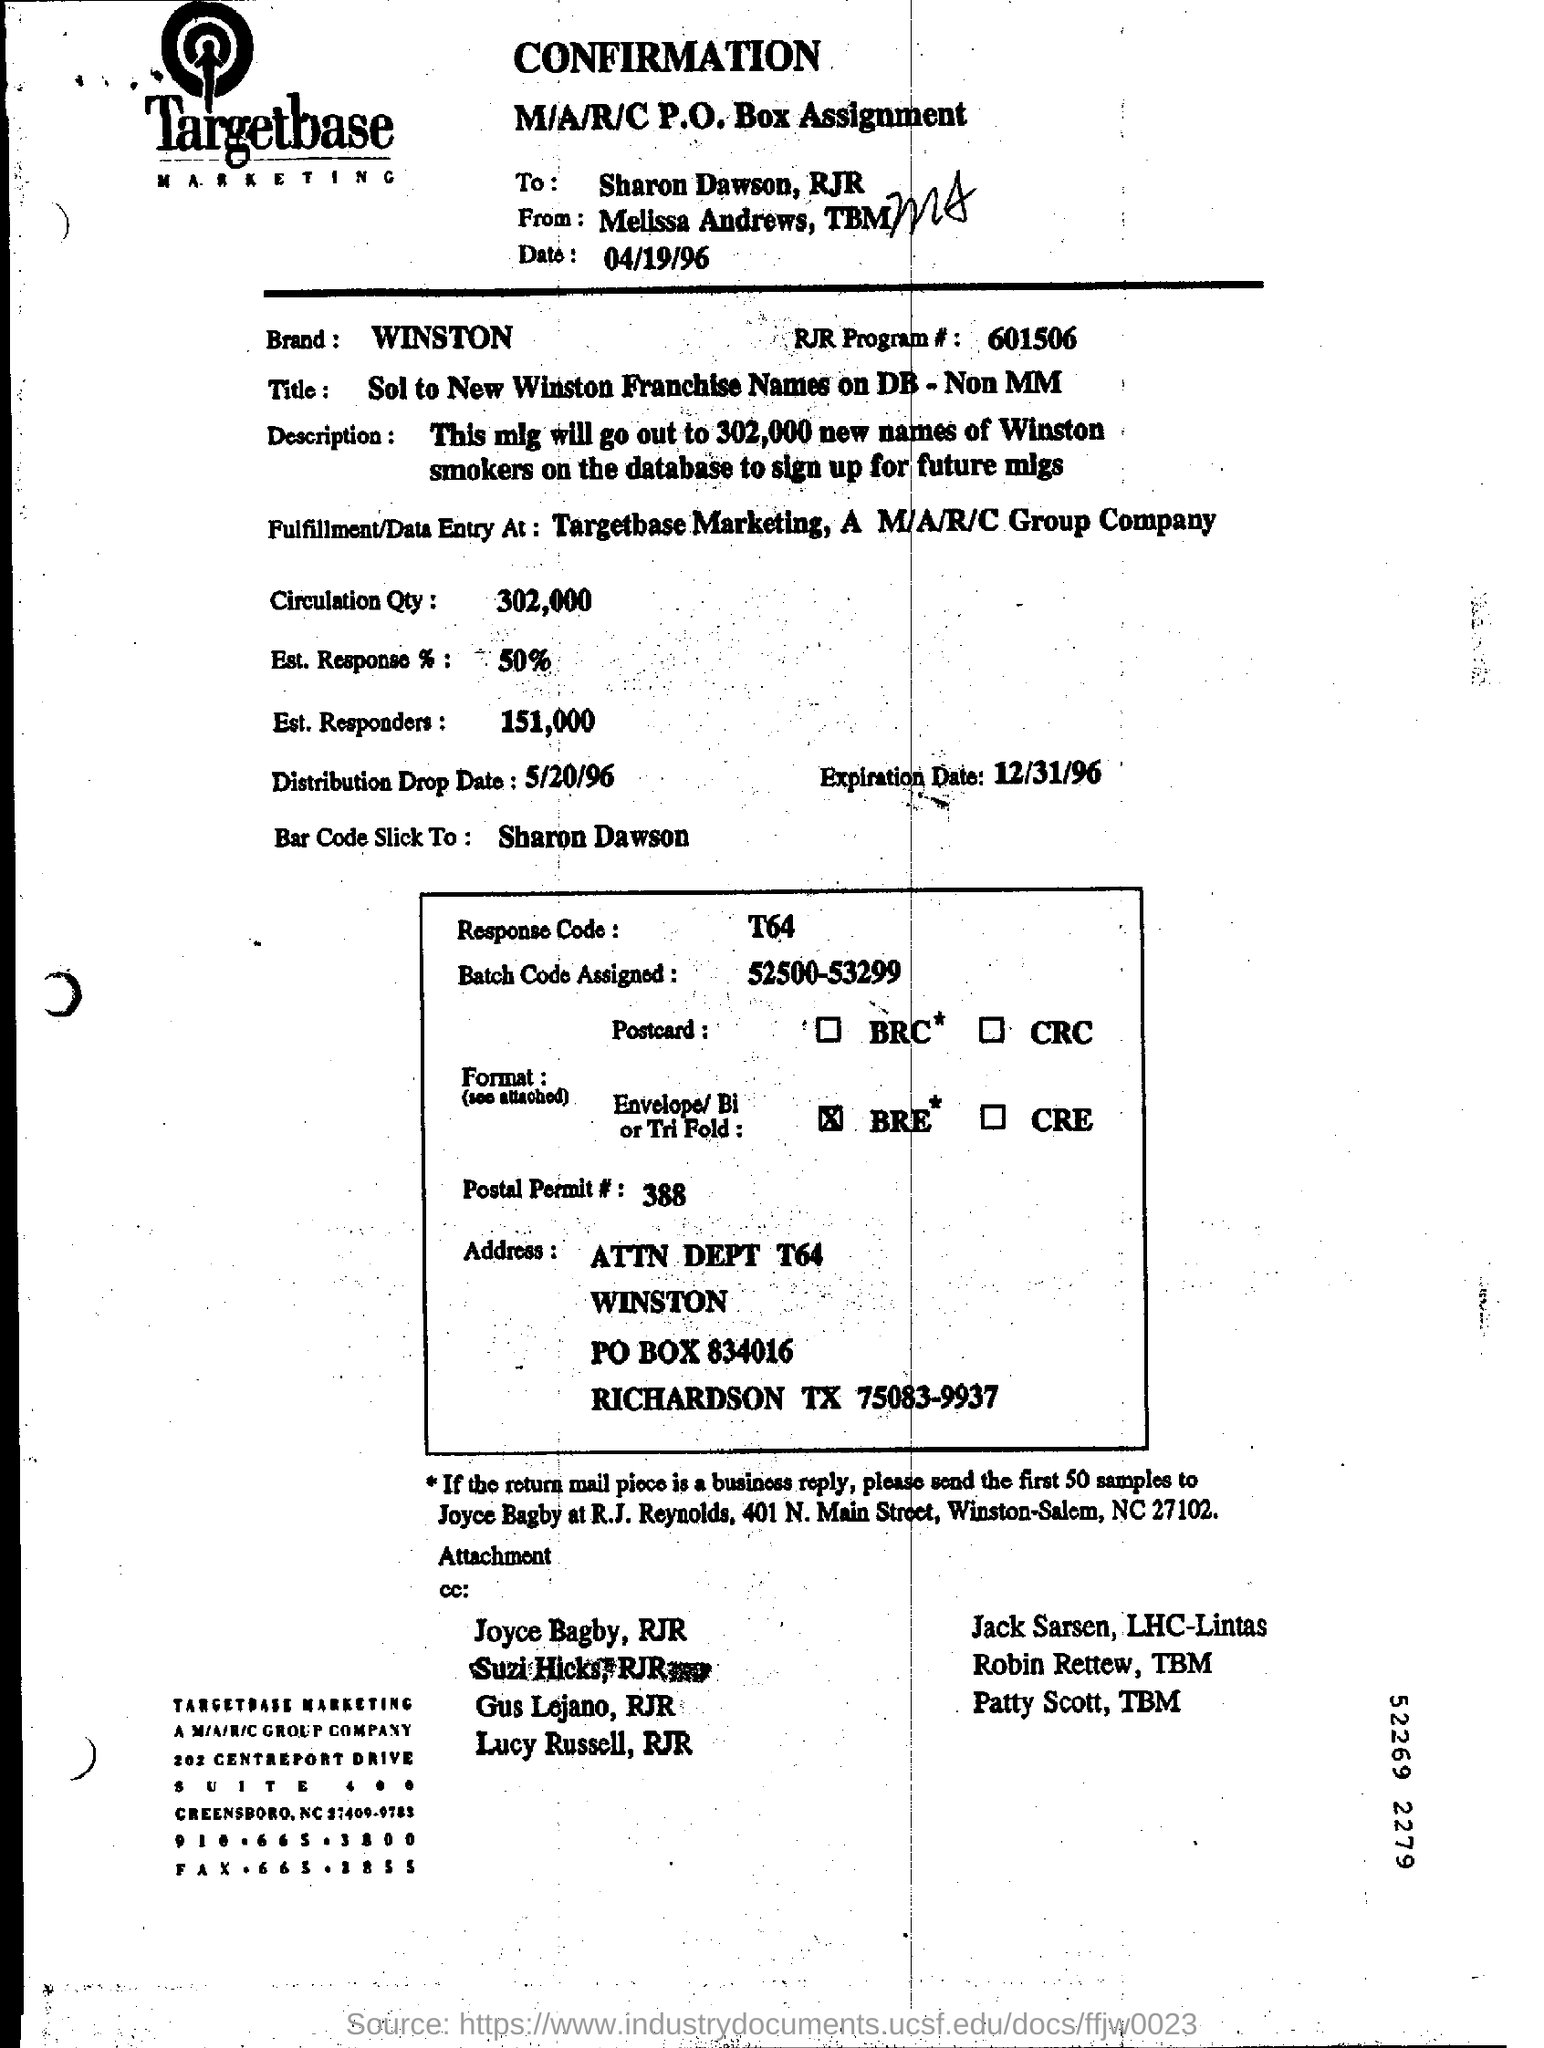What is the distribution drop date mentioned in the document? The distribution drop date indicated on the document is May 20, 1996. 